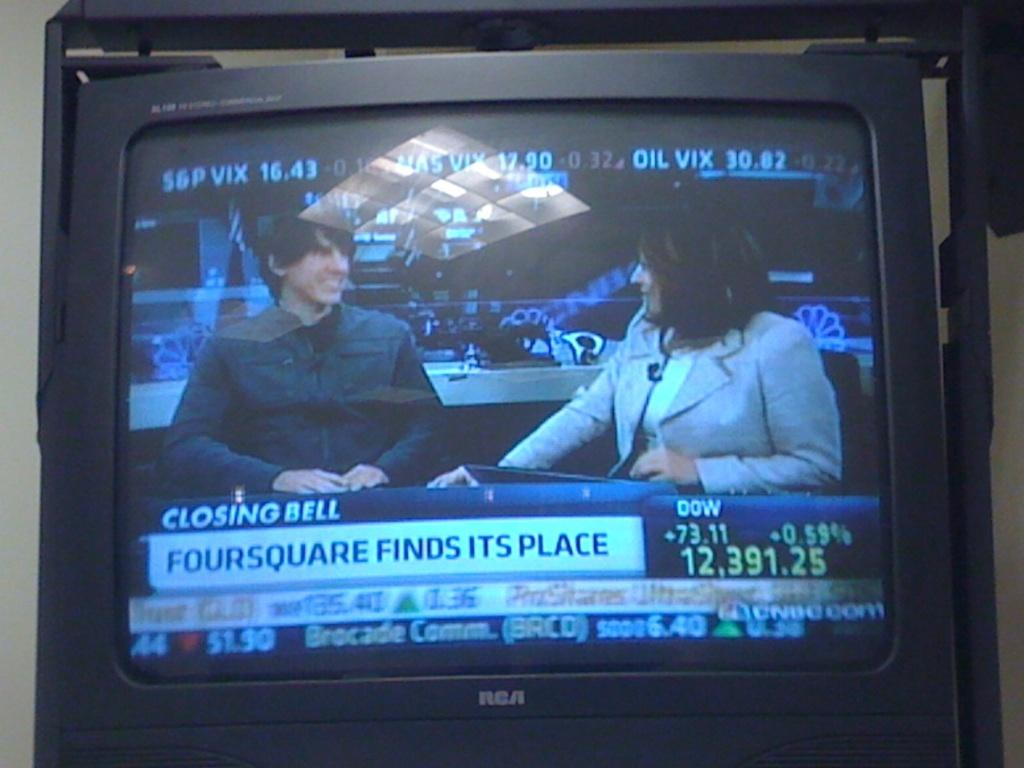<image>
Share a concise interpretation of the image provided. A TV shows a man and a woman talking and it says Closing Bell beneath them. 